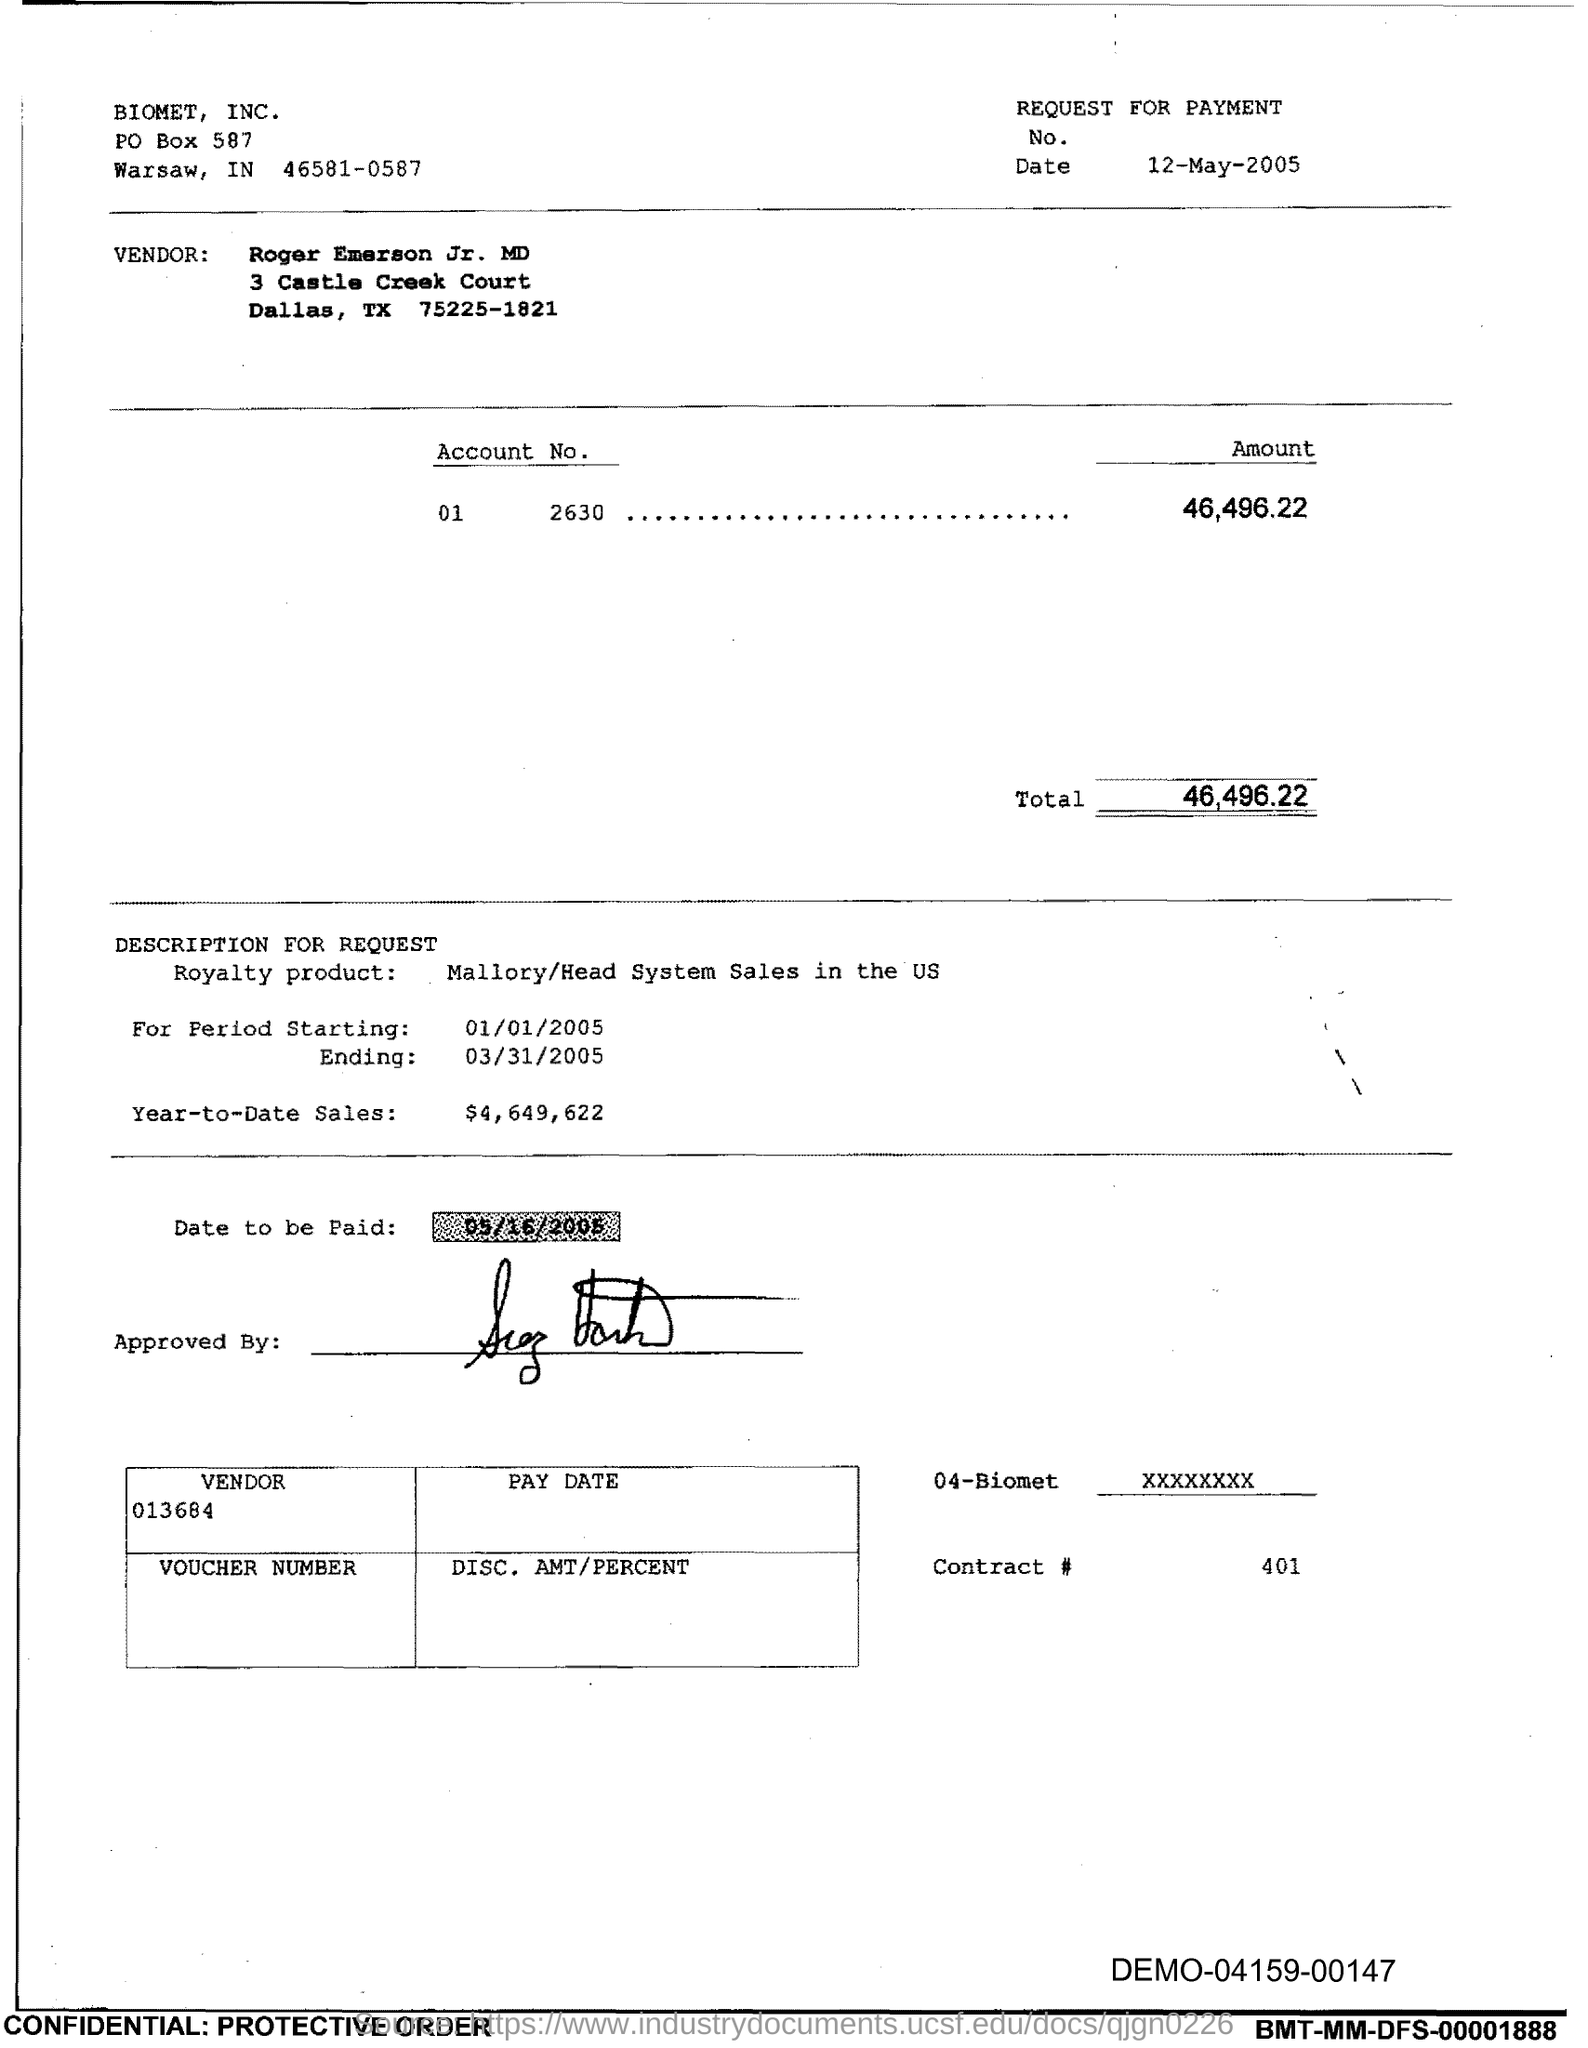Who is the Vendor?
Your response must be concise. Roger Emerson Jr. MD. What is the Amount?
Your answer should be very brief. 46,496.22. What is the Total?
Provide a short and direct response. 46,496.22. What is the Royalty product?
Ensure brevity in your answer.  Mallory/Head System Sales in the US. What is the starting period?
Offer a very short reply. 01/01/2005. What is the ending period?
Offer a very short reply. 03/31/2005. What is the Year-to-date sales?
Offer a very short reply. 4,649,622. When is the date to be paid?
Provide a short and direct response. 05/16/2005. What is the Vendor number?
Provide a succinct answer. 013684. 